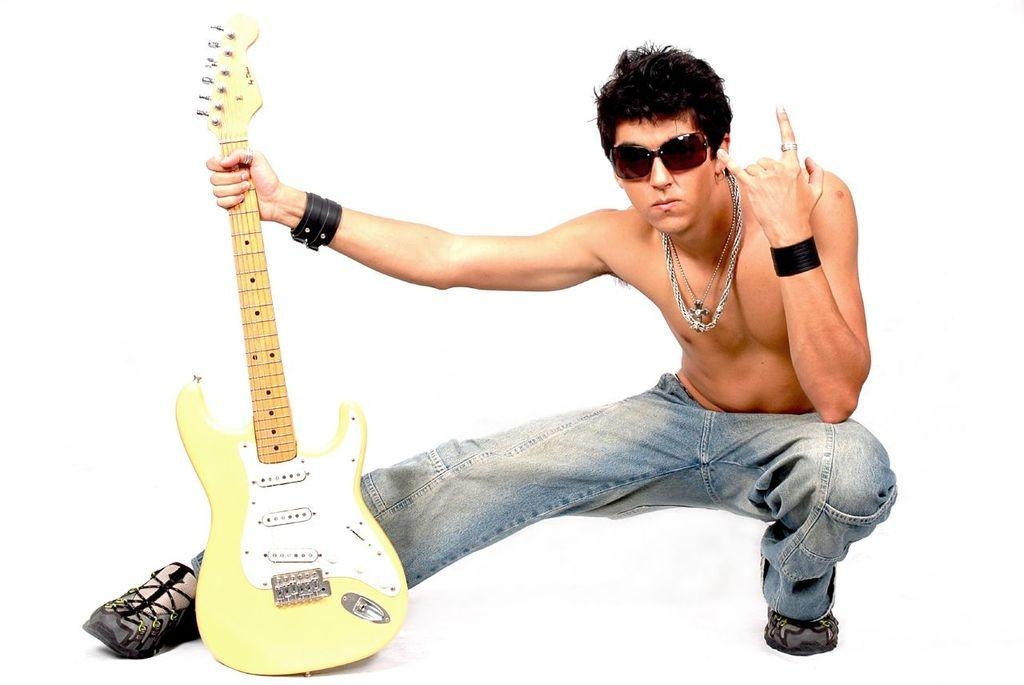What is the main subject of the picture? The main subject of the picture is a man. What is the man wearing on his face? The man is wearing goggles. What accessory is the man wearing on his wrist? The man is wearing a wrist band. What type of jewelry is the man wearing? The man is wearing a chain. What is the man doing in the picture? The man is giving a pose to the camera. What object is the man holding in his hand? The man is holding a guitar in his hand. What type of error can be seen in the image? There is no error visible in the image. What type of government is depicted in the image? There is no government depicted in the image. What type of hole can be seen in the image? There is no hole visible in the image. 